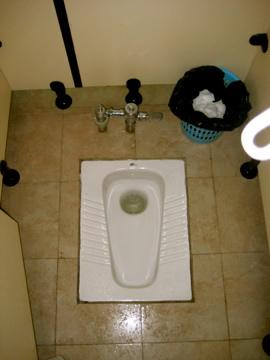Question: what type of flooring is shown?
Choices:
A. Wood.
B. Composite.
C. Tile.
D. Hardwoord.
Answer with the letter. Answer: C Question: where is this shot?
Choices:
A. Bedroom.
B. Office.
C. Bathroom.
D. Kitchen.
Answer with the letter. Answer: C Question: how many animals are shown?
Choices:
A. 1.
B. 0.
C. 3.
D. 4.
Answer with the letter. Answer: B 